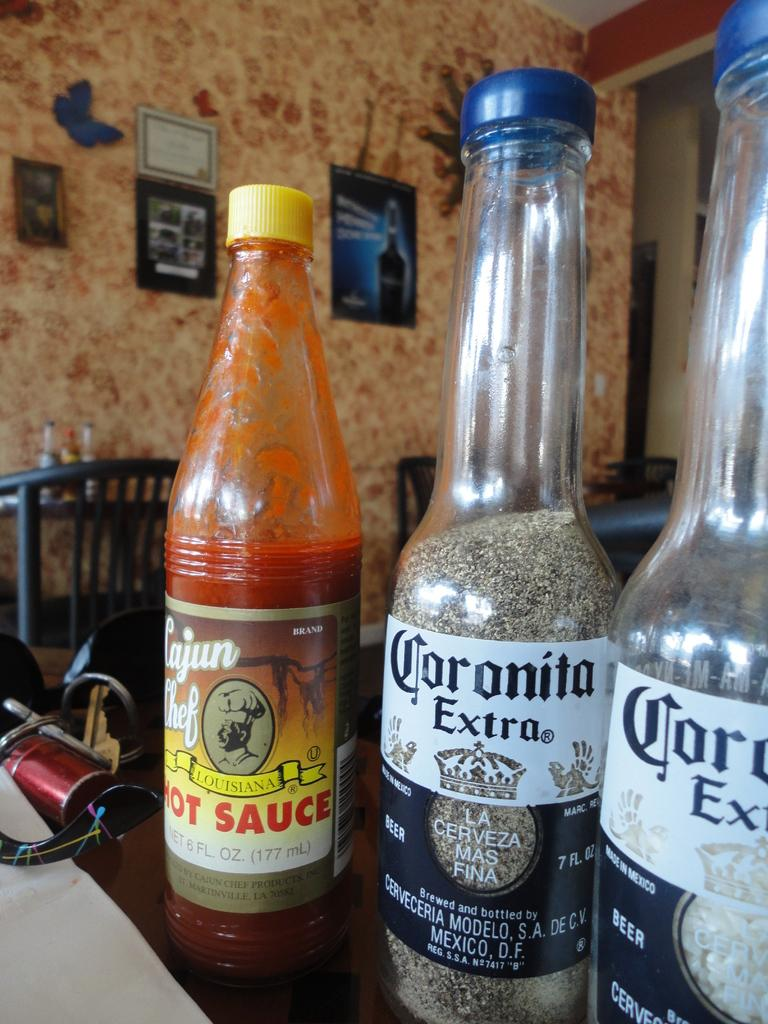<image>
Relay a brief, clear account of the picture shown. Two bottles of Coronita Extra filled with salt and pepper. 